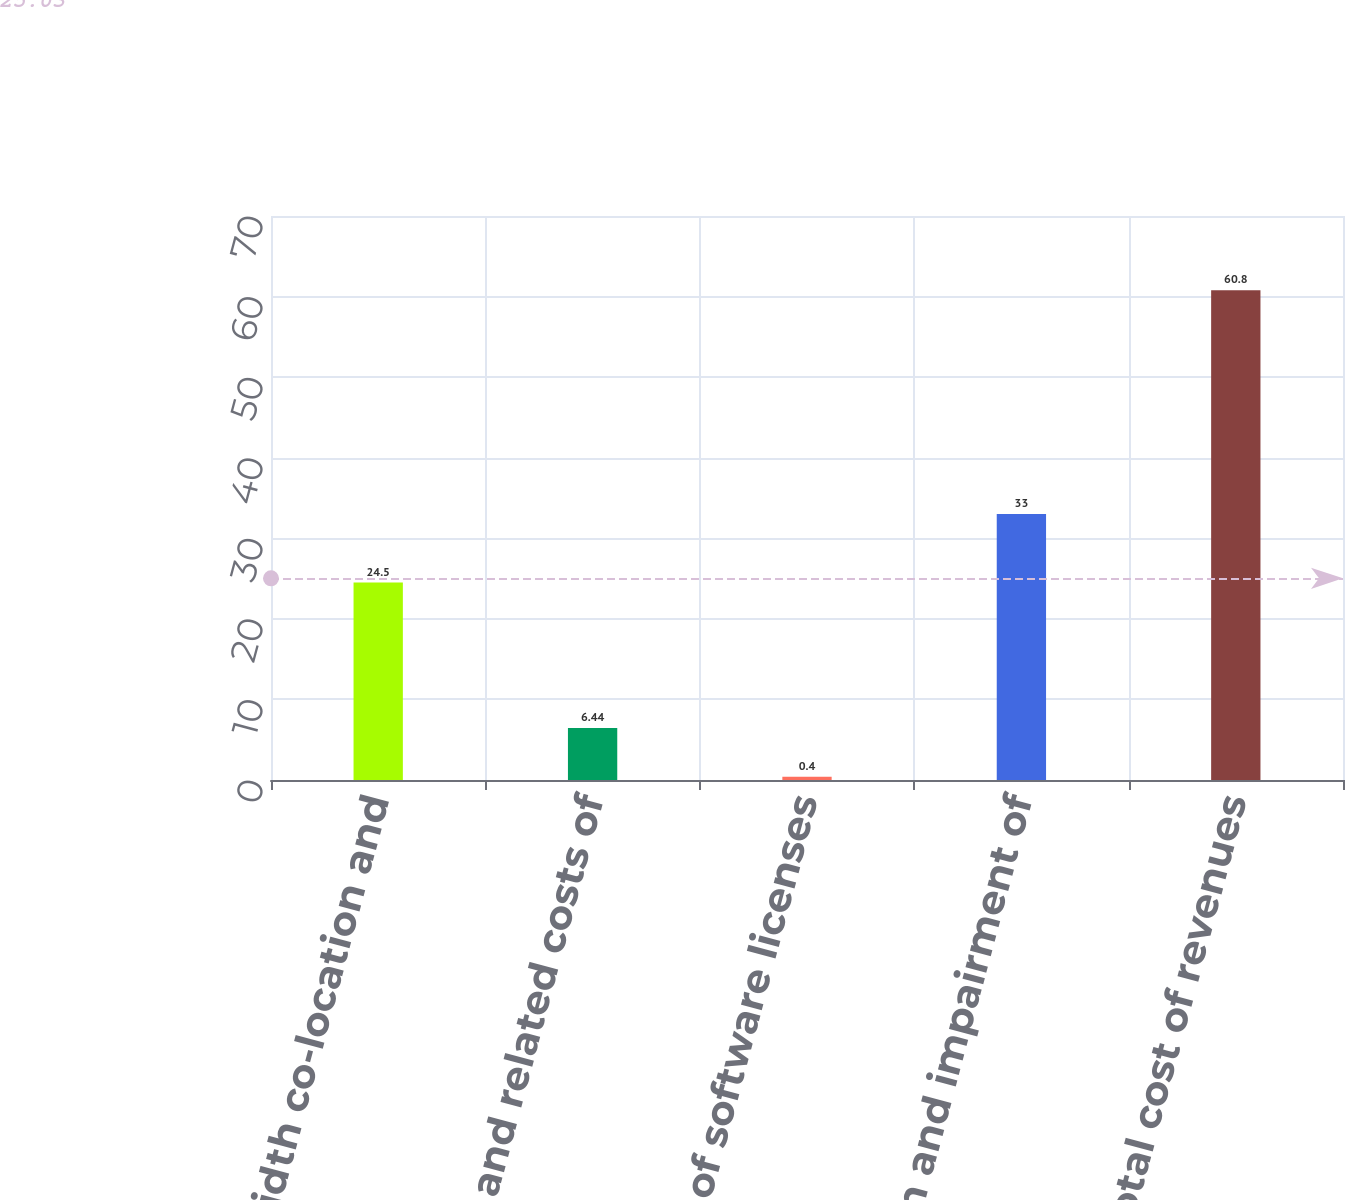<chart> <loc_0><loc_0><loc_500><loc_500><bar_chart><fcel>Bandwidth co-location and<fcel>Payroll and related costs of<fcel>Cost of software licenses<fcel>Depreciation and impairment of<fcel>Total cost of revenues<nl><fcel>24.5<fcel>6.44<fcel>0.4<fcel>33<fcel>60.8<nl></chart> 